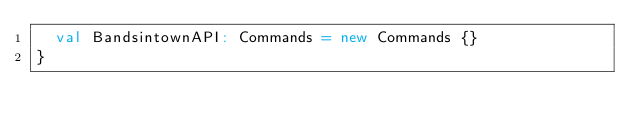<code> <loc_0><loc_0><loc_500><loc_500><_Scala_>  val BandsintownAPI: Commands = new Commands {}
}
</code> 